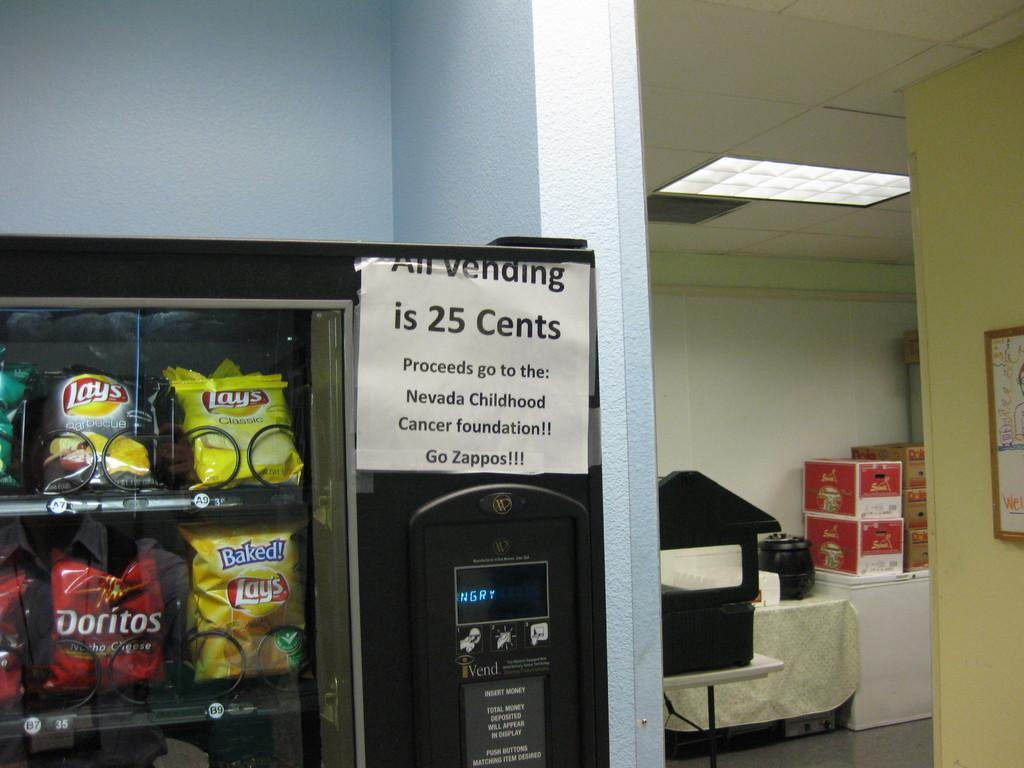<image>
Relay a brief, clear account of the picture shown. A vending machine sign stating that All vending is 25 cents 